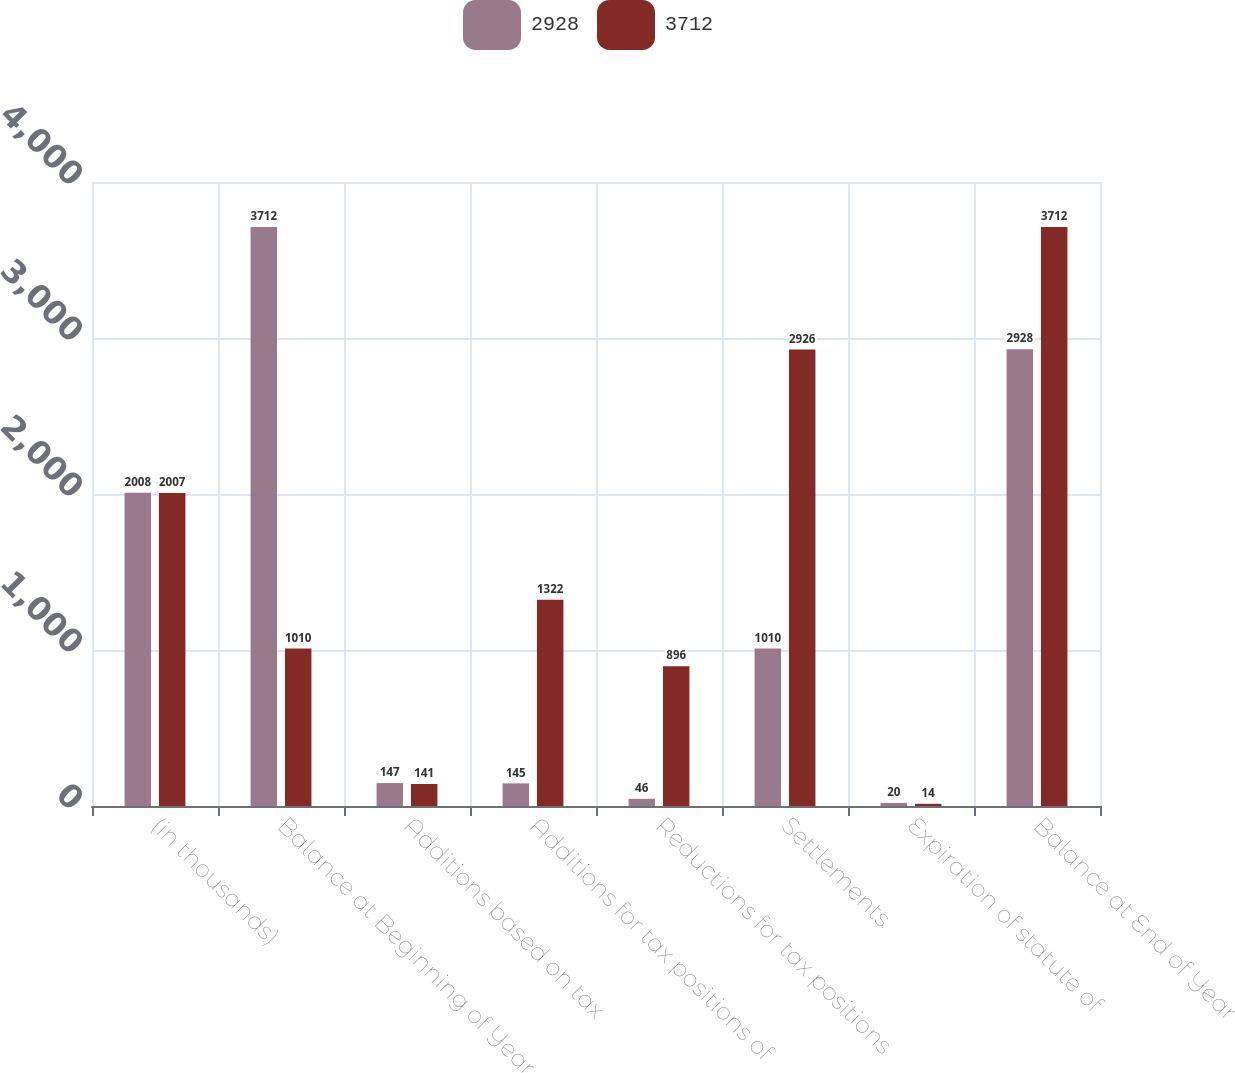<chart> <loc_0><loc_0><loc_500><loc_500><stacked_bar_chart><ecel><fcel>(in thousands)<fcel>Balance at Beginning of Year<fcel>Additions based on tax<fcel>Additions for tax positions of<fcel>Reductions for tax positions<fcel>Settlements<fcel>Expiration of statute of<fcel>Balance at End of Year<nl><fcel>2928<fcel>2008<fcel>3712<fcel>147<fcel>145<fcel>46<fcel>1010<fcel>20<fcel>2928<nl><fcel>3712<fcel>2007<fcel>1010<fcel>141<fcel>1322<fcel>896<fcel>2926<fcel>14<fcel>3712<nl></chart> 